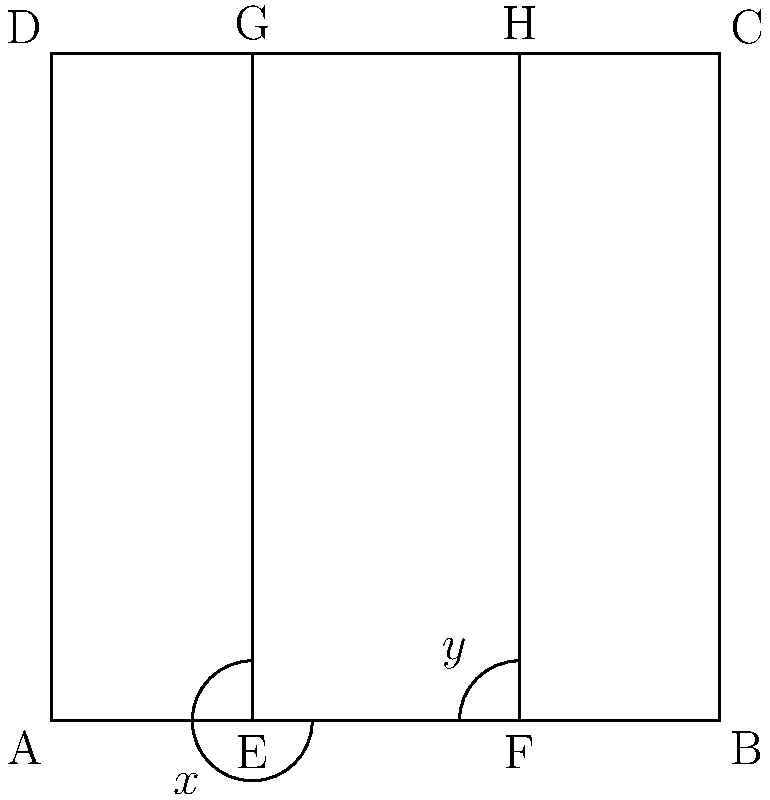In the diagram representing a simplified hockey rink layout, lines EG and FH are goal lines. If angle AEG is congruent to angle BFH, prove that angle x is congruent to angle y. Let's approach this step-by-step:

1) Given: Angle AEG is congruent to angle BFH.

2) In a rectangle, all angles are 90°. Therefore:
   Angle AEG = Angle BFH = 90°

3) In a straight line, angles on a straight line sum to 180°. So:
   x + 90° = 180°
   y + 90° = 180°

4) From step 3, we can derive:
   x = 180° - 90° = 90°
   y = 180° - 90° = 90°

5) Since both x and y equal 90°, we can conclude:
   x = y

6) By the definition of congruent angles, if two angles have the same measure, they are congruent.

Therefore, angle x is congruent to angle y.
Answer: $x \cong y$ because both equal 90° 